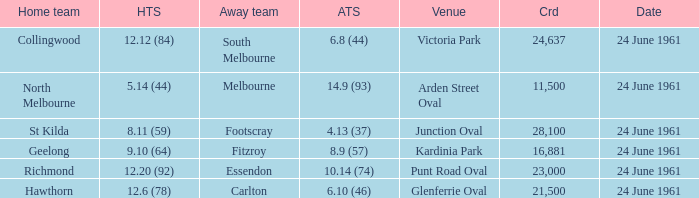Who was the home team that scored 12.6 (78)? Hawthorn. 